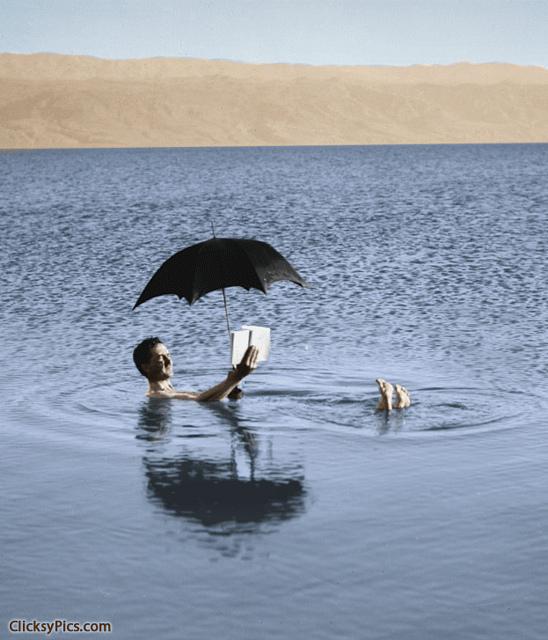Is he reading a book?
Quick response, please. Yes. What landscape is in the background?
Quick response, please. Sand. What are the people holding?
Keep it brief. Umbrella. What kind of art is depicted in this photo? (abstract, impressionist or realist?)?
Quick response, please. Realist. 